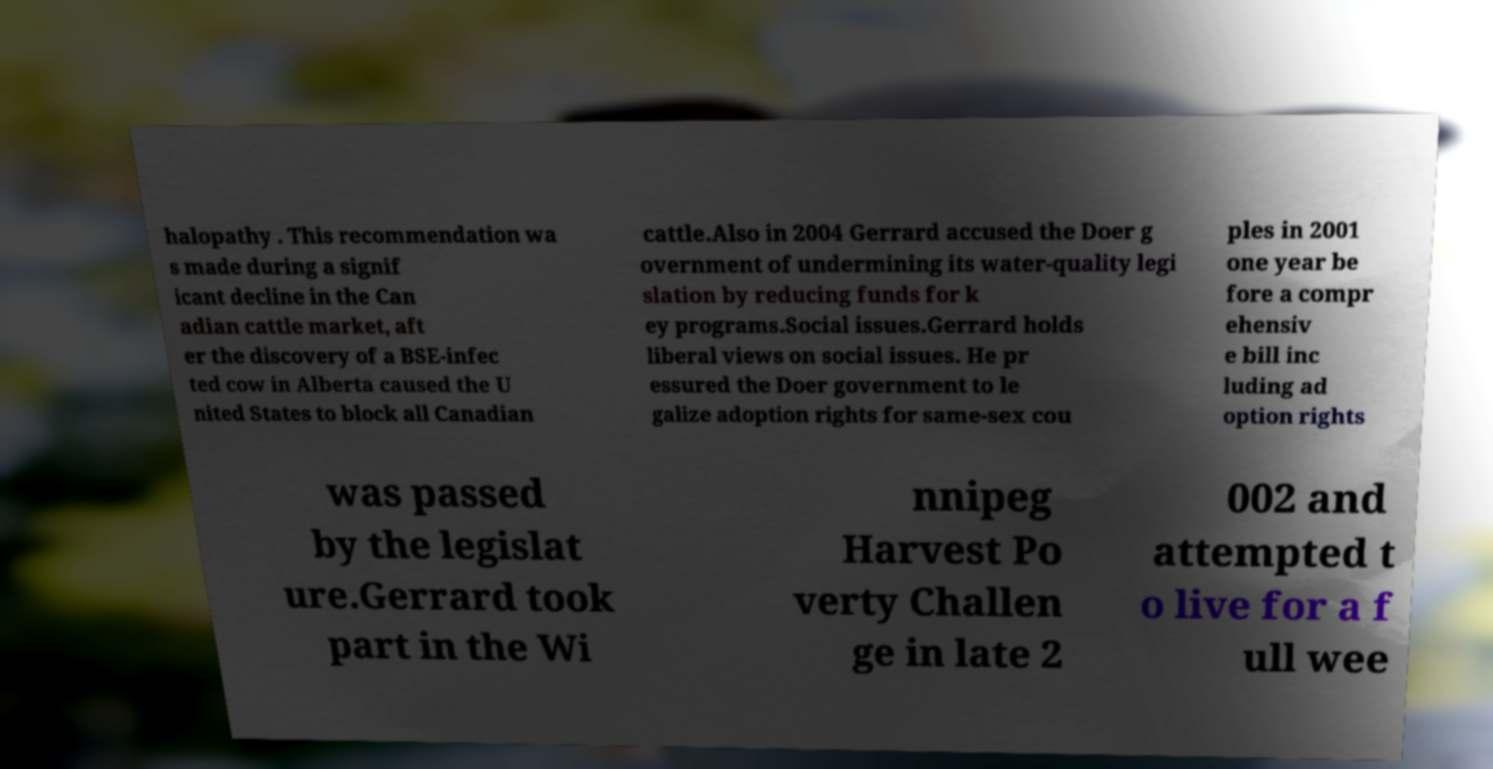Please identify and transcribe the text found in this image. halopathy . This recommendation wa s made during a signif icant decline in the Can adian cattle market, aft er the discovery of a BSE-infec ted cow in Alberta caused the U nited States to block all Canadian cattle.Also in 2004 Gerrard accused the Doer g overnment of undermining its water-quality legi slation by reducing funds for k ey programs.Social issues.Gerrard holds liberal views on social issues. He pr essured the Doer government to le galize adoption rights for same-sex cou ples in 2001 one year be fore a compr ehensiv e bill inc luding ad option rights was passed by the legislat ure.Gerrard took part in the Wi nnipeg Harvest Po verty Challen ge in late 2 002 and attempted t o live for a f ull wee 